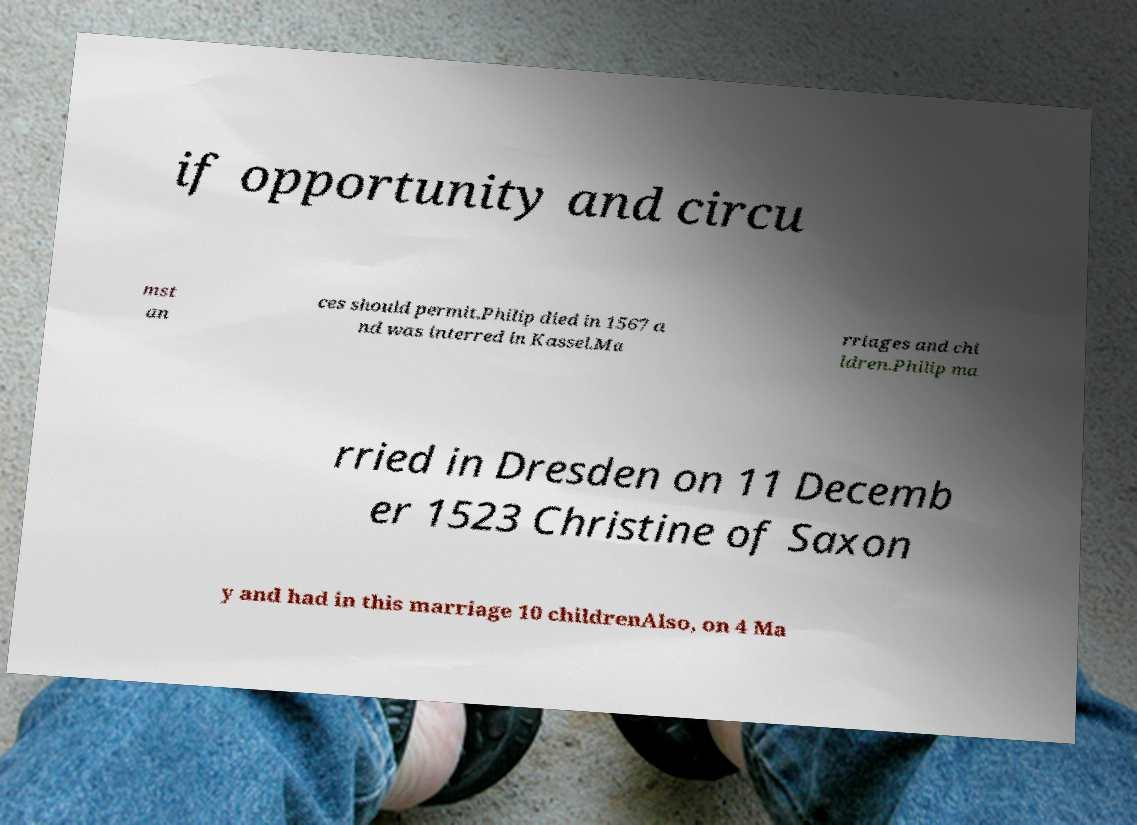I need the written content from this picture converted into text. Can you do that? if opportunity and circu mst an ces should permit.Philip died in 1567 a nd was interred in Kassel.Ma rriages and chi ldren.Philip ma rried in Dresden on 11 Decemb er 1523 Christine of Saxon y and had in this marriage 10 childrenAlso, on 4 Ma 